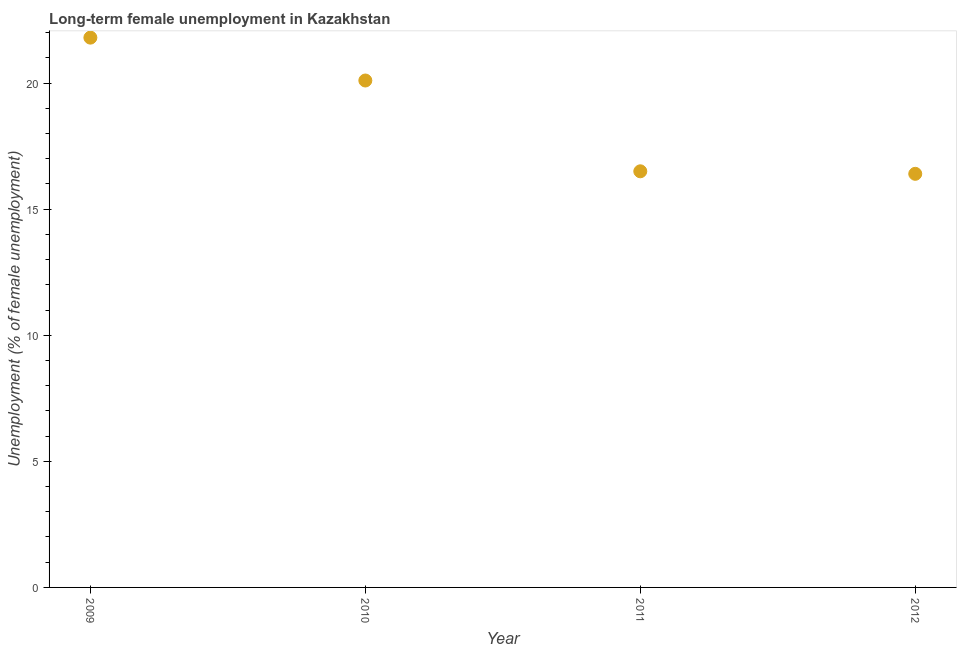What is the long-term female unemployment in 2011?
Keep it short and to the point. 16.5. Across all years, what is the maximum long-term female unemployment?
Provide a short and direct response. 21.8. Across all years, what is the minimum long-term female unemployment?
Keep it short and to the point. 16.4. In which year was the long-term female unemployment maximum?
Your answer should be very brief. 2009. What is the sum of the long-term female unemployment?
Ensure brevity in your answer.  74.8. What is the difference between the long-term female unemployment in 2010 and 2011?
Provide a short and direct response. 3.6. What is the average long-term female unemployment per year?
Your answer should be very brief. 18.7. What is the median long-term female unemployment?
Give a very brief answer. 18.3. In how many years, is the long-term female unemployment greater than 21 %?
Make the answer very short. 1. What is the ratio of the long-term female unemployment in 2010 to that in 2012?
Provide a short and direct response. 1.23. Is the long-term female unemployment in 2010 less than that in 2012?
Provide a succinct answer. No. What is the difference between the highest and the second highest long-term female unemployment?
Ensure brevity in your answer.  1.7. What is the difference between the highest and the lowest long-term female unemployment?
Provide a short and direct response. 5.4. Does the long-term female unemployment monotonically increase over the years?
Offer a very short reply. No. How many dotlines are there?
Your answer should be compact. 1. How many years are there in the graph?
Provide a short and direct response. 4. Are the values on the major ticks of Y-axis written in scientific E-notation?
Your response must be concise. No. Does the graph contain grids?
Provide a short and direct response. No. What is the title of the graph?
Your response must be concise. Long-term female unemployment in Kazakhstan. What is the label or title of the Y-axis?
Provide a succinct answer. Unemployment (% of female unemployment). What is the Unemployment (% of female unemployment) in 2009?
Your answer should be compact. 21.8. What is the Unemployment (% of female unemployment) in 2010?
Provide a short and direct response. 20.1. What is the Unemployment (% of female unemployment) in 2011?
Make the answer very short. 16.5. What is the Unemployment (% of female unemployment) in 2012?
Make the answer very short. 16.4. What is the difference between the Unemployment (% of female unemployment) in 2009 and 2011?
Offer a very short reply. 5.3. What is the difference between the Unemployment (% of female unemployment) in 2011 and 2012?
Your response must be concise. 0.1. What is the ratio of the Unemployment (% of female unemployment) in 2009 to that in 2010?
Give a very brief answer. 1.08. What is the ratio of the Unemployment (% of female unemployment) in 2009 to that in 2011?
Your response must be concise. 1.32. What is the ratio of the Unemployment (% of female unemployment) in 2009 to that in 2012?
Your response must be concise. 1.33. What is the ratio of the Unemployment (% of female unemployment) in 2010 to that in 2011?
Offer a very short reply. 1.22. What is the ratio of the Unemployment (% of female unemployment) in 2010 to that in 2012?
Give a very brief answer. 1.23. 